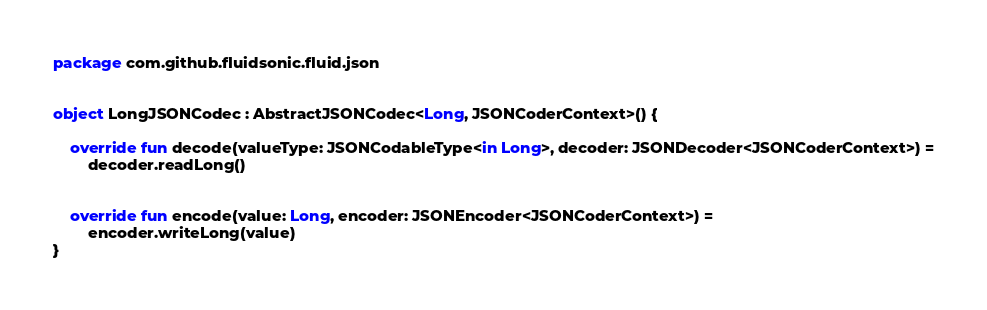<code> <loc_0><loc_0><loc_500><loc_500><_Kotlin_>package com.github.fluidsonic.fluid.json


object LongJSONCodec : AbstractJSONCodec<Long, JSONCoderContext>() {

	override fun decode(valueType: JSONCodableType<in Long>, decoder: JSONDecoder<JSONCoderContext>) =
		decoder.readLong()


	override fun encode(value: Long, encoder: JSONEncoder<JSONCoderContext>) =
		encoder.writeLong(value)
}
</code> 